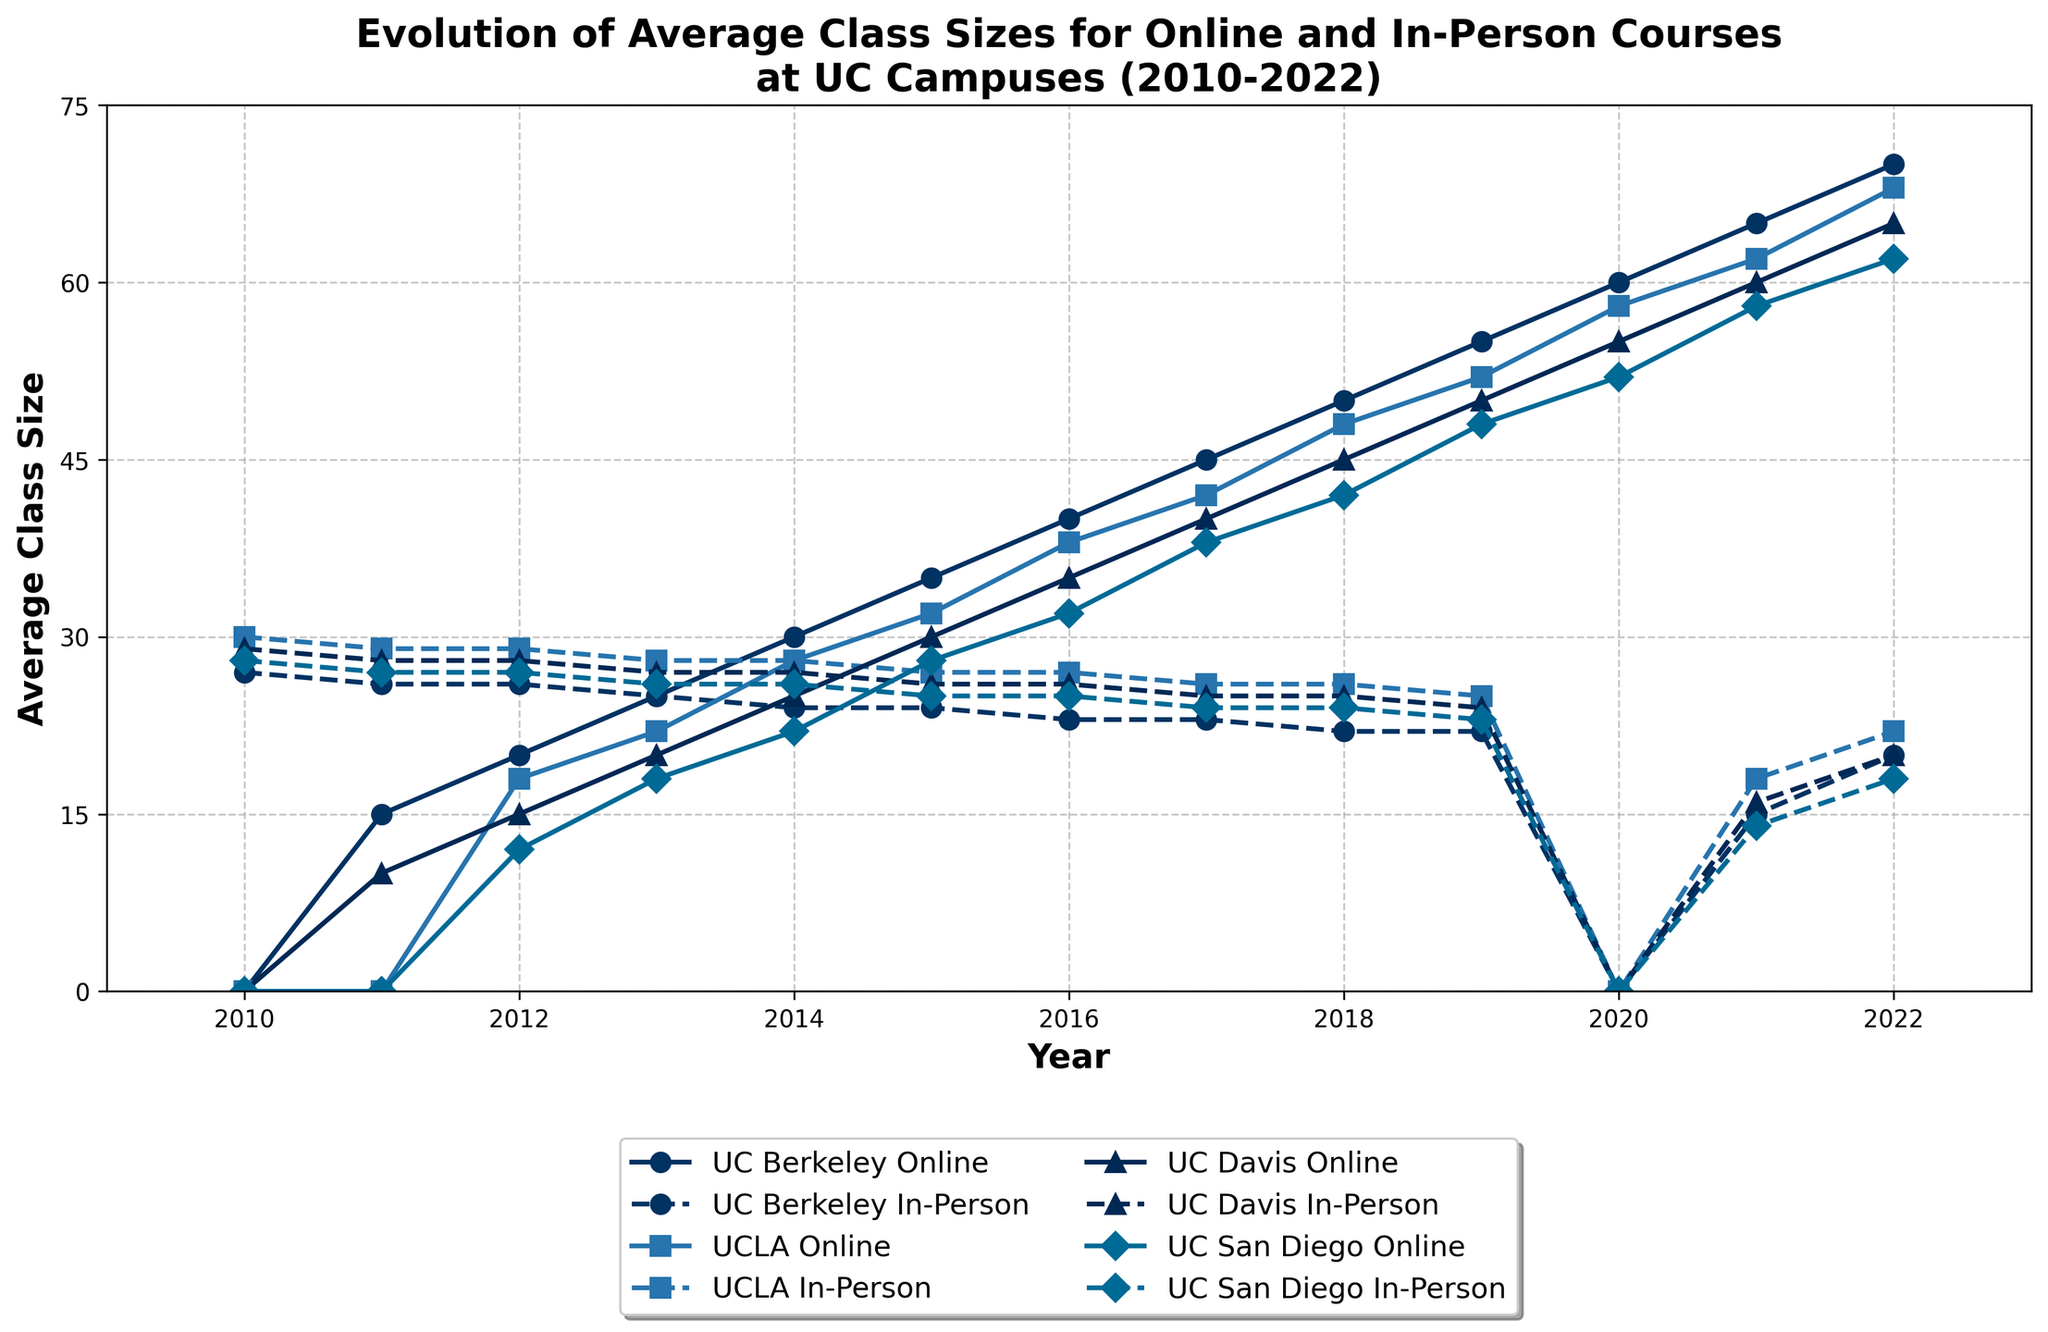Which UC campus had the largest online average class size in 2022? To determine this, compare the online average class sizes for all four campuses in 2022. UC Berkeley's online class size is 70, UCLA's is 68, UC Davis's is 65, and UC San Diego's is 62. Therefore, UC Berkeley had the largest online class size.
Answer: UC Berkeley How much did the average class size for in-person courses at UC Berkeley decrease from 2010 to 2022? In 2010, UC Berkeley's in-person average class size was 27, and it reduced to 20 in 2022. Subtracting these values gives a decrease of 27 - 20 = 7.
Answer: 7 What's the average increase in online class sizes at UCLA from 2010 to 2022? First, note that the online class size grew from 0 in 2010 to 68 in 2022. The total increase is 68 - 0 = 68. This increase happened over 12 years (2010 to 2022), so the average annual increase is 68 / 12 ≈ 5.67.
Answer: 5.67 Which UC campus experienced the most significant decline in in-person class sizes from 2010 to 2018? Compare the changes for each campus by finding the difference between their 2010 and 2018 in-person class sizes: UC Berkeley: 27 - 22 = 5, UCLA: 30 - 26 = 4, UC Davis: 29 - 25 = 4, UC San Diego: 28 - 24 = 4. UC Berkeley experienced the most significant decline at 5.
Answer: UC Berkeley In what year did UC Davis's online class size surpass its in-person class size for the first time? Check the data for UC Davis. The online class size surpassed the in-person class size in 2020. In 2020, online was 55 and in-person was 0.
Answer: 2020 What is the median online class size for UC San Diego over the entire period displayed in the chart? List the online class sizes for each year from 2010 to 2022 (excluding 0 values at the beginning): [12, 18, 22, 28, 32, 38, 42, 48, 52, 58, 62]. The median is the middle value in this ordered list, which is 38.
Answer: 38 Between which consecutive years did UCLA experience the most significant increase in online class size? Calculate the yearly increase in online class size for UCLA, and identify the pair of consecutive years with the largest increase. The most significant increase occurred between 2010 and 2011, rising from 0 to 15, an increase of 15.
Answer: 2010-2011 How does the average in-person class size trend at UC San Diego from 2010 to 2022? Review the in-person sizes: [28, 27, 27, 26, 26, 25, 25, 24, 24, 23, 0, 14, 18]. Generally, the trend shows a decrease until 2020, then a slight recovery.
Answer: Decreasing then recovering What was the difference between the online and in-person class sizes at UC Berkeley in 2018? For UC Berkeley in 2018, the online class size was 50, and the in-person class size was 22. The difference is thus 50 - 22 = 28.
Answer: 28 